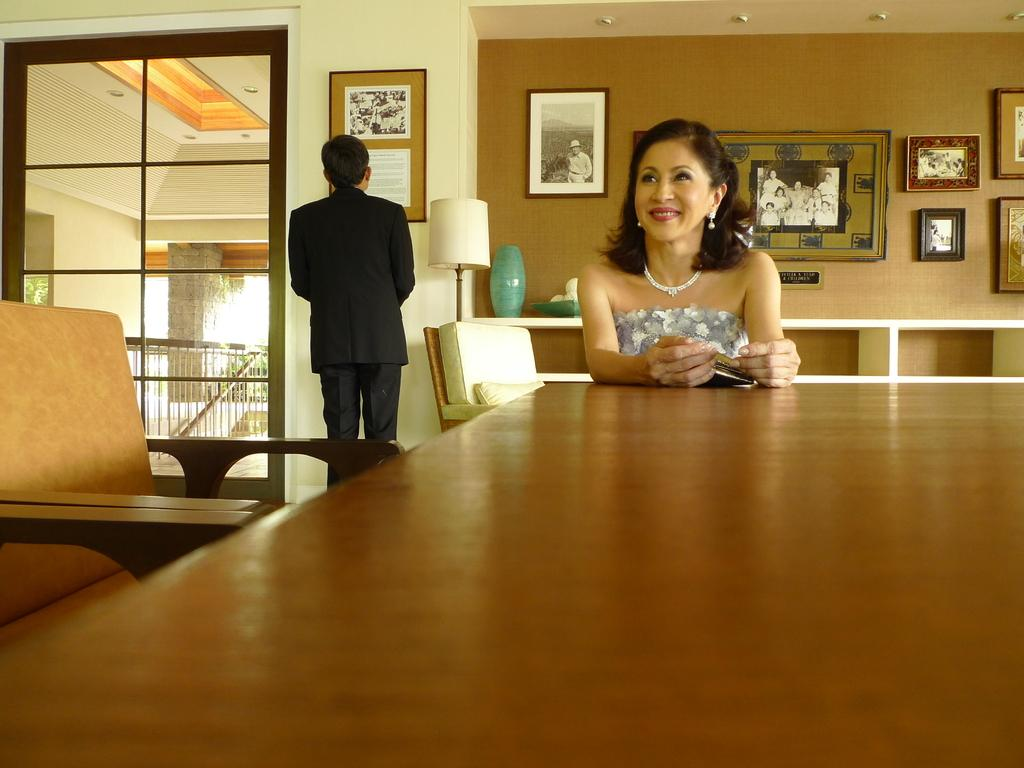What is the woman doing in the image? The woman is sitting in front of a table in the image. What is the man doing in the image? The man is standing on the left side of the image and staring at a painting. Where are the photographs located in the image? The photographs are on the back side wall in the image. What statement does the woman make about her aunt in the image? There is no mention of an aunt or any statement made by the woman in the image. 